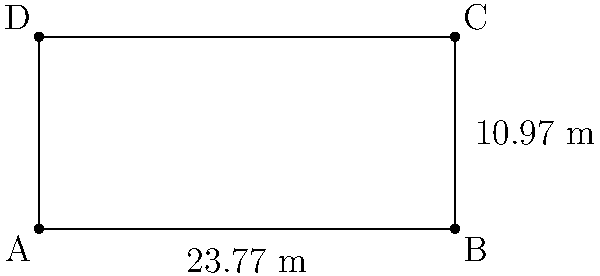As a sports journalist covering tennis events, you need to report on the playing area. Given the dimensions of a tennis court shown in the diagram, calculate its total area in square meters. Round your answer to two decimal places. To calculate the area of the tennis court, we need to follow these steps:

1. Identify the shape: The tennis court is a rectangle.

2. Recall the formula for the area of a rectangle:
   $A = l \times w$, where $A$ is area, $l$ is length, and $w$ is width.

3. Identify the dimensions:
   Length ($l$) = 23.77 m
   Width ($w$) = 10.97 m

4. Apply the formula:
   $A = 23.77 \text{ m} \times 10.97 \text{ m}$

5. Perform the calculation:
   $A = 260.7569 \text{ m}^2$

6. Round to two decimal places:
   $A \approx 260.76 \text{ m}^2$

Therefore, the total area of the tennis court is approximately 260.76 square meters.
Answer: $260.76 \text{ m}^2$ 